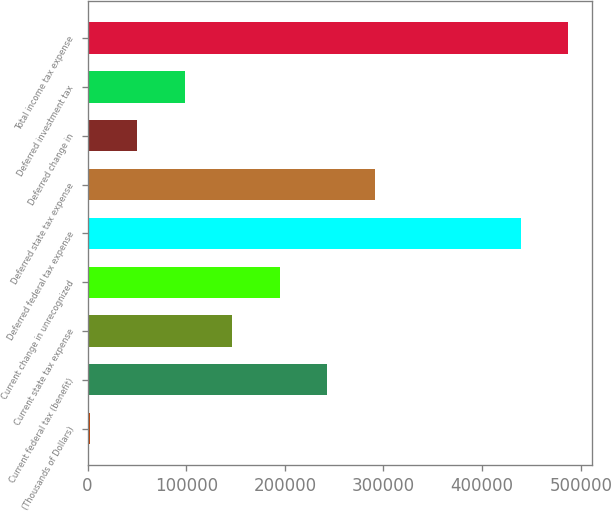Convert chart. <chart><loc_0><loc_0><loc_500><loc_500><bar_chart><fcel>(Thousands of Dollars)<fcel>Current federal tax (benefit)<fcel>Current state tax expense<fcel>Current change in unrecognized<fcel>Deferred federal tax expense<fcel>Deferred state tax expense<fcel>Deferred change in<fcel>Deferred investment tax<fcel>Total income tax expense<nl><fcel>2013<fcel>242994<fcel>146602<fcel>194798<fcel>439085<fcel>291191<fcel>50209.3<fcel>98405.6<fcel>487281<nl></chart> 